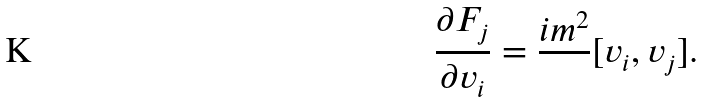<formula> <loc_0><loc_0><loc_500><loc_500>\frac { \partial F _ { j } } { \partial v _ { i } } = \frac { i m ^ { 2 } } { } [ v _ { i } , v _ { j } ] .</formula> 